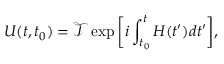Convert formula to latex. <formula><loc_0><loc_0><loc_500><loc_500>U ( t , t _ { 0 } ) = \mathcal { T } \exp \left [ i \int _ { t _ { 0 } } ^ { t } H ( t ^ { \prime } ) d t ^ { \prime } \right ] ,</formula> 